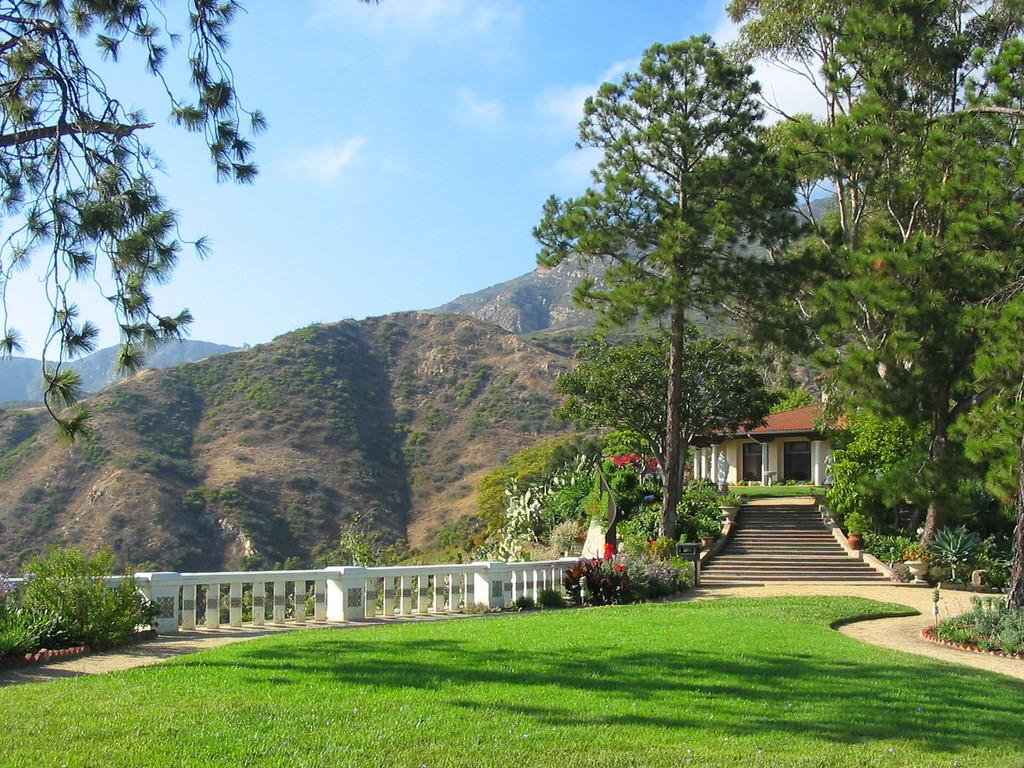What type of landscape is depicted in the image? The image contains a scenery with hills. What kind of vegetation can be seen in the image? There are trees in the image. Can you describe the house in the image? The house has steps and a railing in the image. What is the ground surface like in the image? There is a grass surface in the image. What can be seen in the background of the image? There is a sky visible in the background of the image, with clouds present. How many jellyfish are swimming in the grass in the image? There are no jellyfish present in the image, as it features a landscape with hills, trees, a house, and grass. 